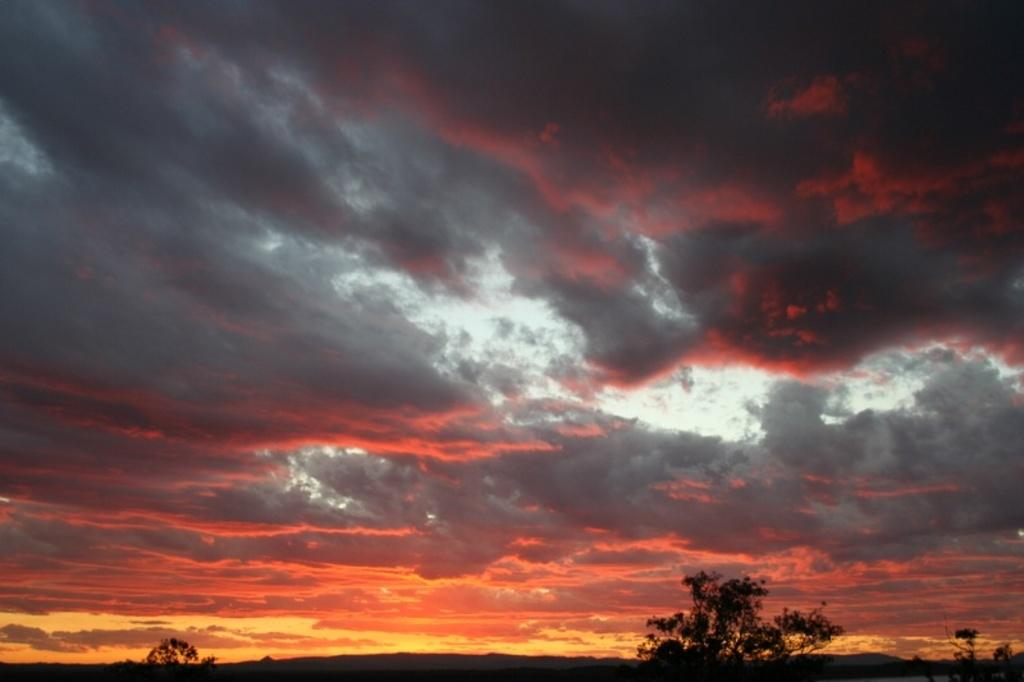What type of vegetation is at the bottom of the image? There are trees at the bottom of the image. What is visible at the top of the image? The sky is visible at the top of the image. What is the color of the sky in the image? The sky has an orange color. Can you see a girl sitting in a nest in the image? There is no girl or nest present in the image. What type of string is hanging from the trees in the image? There is no string visible in the image; only trees and an orange sky are present. 